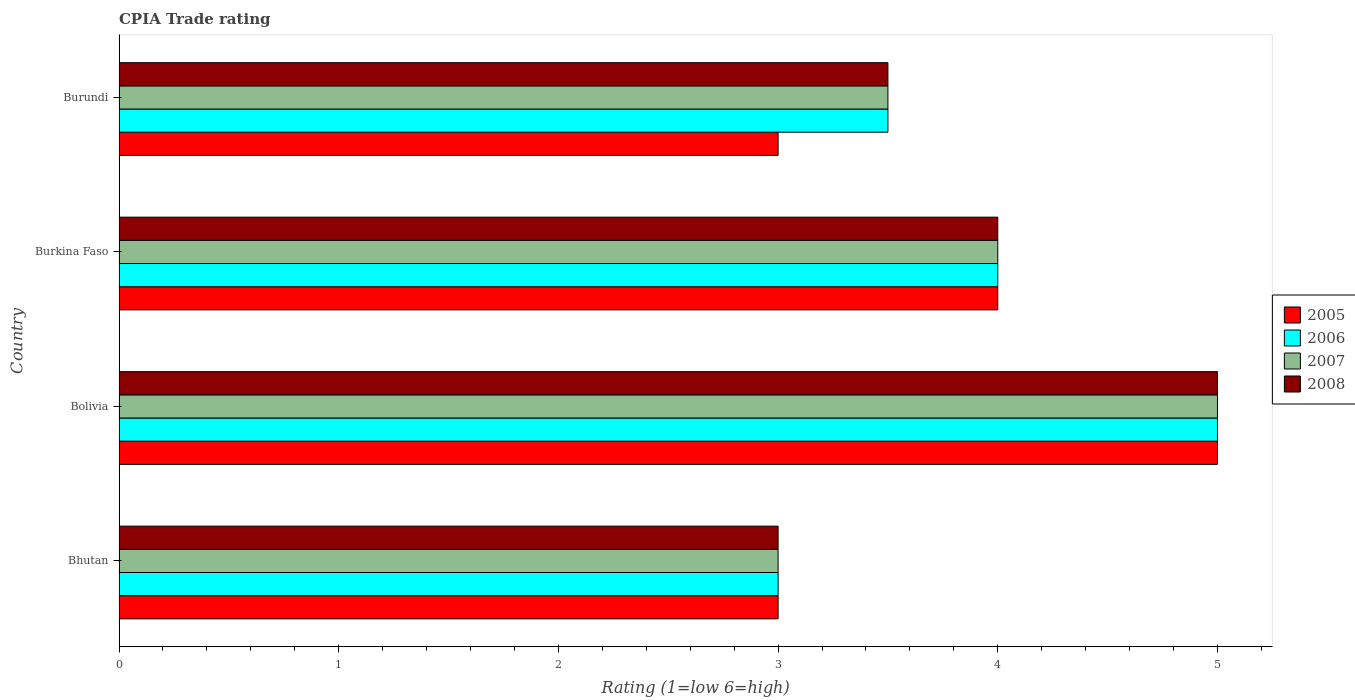How many different coloured bars are there?
Make the answer very short. 4. How many bars are there on the 2nd tick from the top?
Provide a succinct answer. 4. What is the label of the 1st group of bars from the top?
Your answer should be compact. Burundi. In how many cases, is the number of bars for a given country not equal to the number of legend labels?
Your answer should be very brief. 0. What is the CPIA rating in 2007 in Burundi?
Provide a short and direct response. 3.5. In which country was the CPIA rating in 2005 minimum?
Give a very brief answer. Bhutan. What is the total CPIA rating in 2008 in the graph?
Your answer should be compact. 15.5. What is the difference between the CPIA rating in 2006 in Bhutan and that in Burundi?
Offer a terse response. -0.5. What is the average CPIA rating in 2007 per country?
Offer a very short reply. 3.88. What is the difference between the CPIA rating in 2005 and CPIA rating in 2008 in Bolivia?
Make the answer very short. 0. What is the ratio of the CPIA rating in 2007 in Bhutan to that in Bolivia?
Give a very brief answer. 0.6. Is the CPIA rating in 2008 in Bhutan less than that in Bolivia?
Make the answer very short. Yes. In how many countries, is the CPIA rating in 2008 greater than the average CPIA rating in 2008 taken over all countries?
Provide a short and direct response. 2. Is it the case that in every country, the sum of the CPIA rating in 2007 and CPIA rating in 2008 is greater than the sum of CPIA rating in 2005 and CPIA rating in 2006?
Keep it short and to the point. No. How many bars are there?
Offer a terse response. 16. Are all the bars in the graph horizontal?
Keep it short and to the point. Yes. Does the graph contain any zero values?
Your answer should be compact. No. Where does the legend appear in the graph?
Ensure brevity in your answer.  Center right. How are the legend labels stacked?
Your answer should be compact. Vertical. What is the title of the graph?
Offer a very short reply. CPIA Trade rating. What is the label or title of the X-axis?
Your answer should be compact. Rating (1=low 6=high). What is the label or title of the Y-axis?
Offer a terse response. Country. What is the Rating (1=low 6=high) of 2006 in Bhutan?
Keep it short and to the point. 3. What is the Rating (1=low 6=high) in 2007 in Bhutan?
Give a very brief answer. 3. What is the Rating (1=low 6=high) of 2005 in Burkina Faso?
Provide a short and direct response. 4. What is the Rating (1=low 6=high) of 2006 in Burkina Faso?
Give a very brief answer. 4. What is the Rating (1=low 6=high) of 2008 in Burkina Faso?
Offer a very short reply. 4. What is the Rating (1=low 6=high) of 2006 in Burundi?
Give a very brief answer. 3.5. What is the Rating (1=low 6=high) in 2007 in Burundi?
Your answer should be very brief. 3.5. Across all countries, what is the minimum Rating (1=low 6=high) of 2005?
Give a very brief answer. 3. What is the total Rating (1=low 6=high) of 2005 in the graph?
Provide a succinct answer. 15. What is the total Rating (1=low 6=high) in 2006 in the graph?
Provide a succinct answer. 15.5. What is the total Rating (1=low 6=high) of 2007 in the graph?
Make the answer very short. 15.5. What is the difference between the Rating (1=low 6=high) in 2005 in Bhutan and that in Bolivia?
Give a very brief answer. -2. What is the difference between the Rating (1=low 6=high) of 2008 in Bhutan and that in Bolivia?
Your response must be concise. -2. What is the difference between the Rating (1=low 6=high) in 2006 in Bhutan and that in Burkina Faso?
Your answer should be very brief. -1. What is the difference between the Rating (1=low 6=high) of 2007 in Bhutan and that in Burkina Faso?
Make the answer very short. -1. What is the difference between the Rating (1=low 6=high) of 2008 in Bhutan and that in Burkina Faso?
Offer a terse response. -1. What is the difference between the Rating (1=low 6=high) of 2007 in Bhutan and that in Burundi?
Your answer should be compact. -0.5. What is the difference between the Rating (1=low 6=high) in 2008 in Bhutan and that in Burundi?
Provide a short and direct response. -0.5. What is the difference between the Rating (1=low 6=high) of 2005 in Bolivia and that in Burkina Faso?
Keep it short and to the point. 1. What is the difference between the Rating (1=low 6=high) in 2006 in Bolivia and that in Burkina Faso?
Your answer should be compact. 1. What is the difference between the Rating (1=low 6=high) in 2007 in Bolivia and that in Burkina Faso?
Ensure brevity in your answer.  1. What is the difference between the Rating (1=low 6=high) in 2008 in Bolivia and that in Burkina Faso?
Provide a short and direct response. 1. What is the difference between the Rating (1=low 6=high) in 2006 in Bolivia and that in Burundi?
Your answer should be compact. 1.5. What is the difference between the Rating (1=low 6=high) of 2007 in Bolivia and that in Burundi?
Your response must be concise. 1.5. What is the difference between the Rating (1=low 6=high) in 2008 in Bolivia and that in Burundi?
Offer a terse response. 1.5. What is the difference between the Rating (1=low 6=high) of 2006 in Burkina Faso and that in Burundi?
Provide a succinct answer. 0.5. What is the difference between the Rating (1=low 6=high) of 2007 in Burkina Faso and that in Burundi?
Offer a terse response. 0.5. What is the difference between the Rating (1=low 6=high) of 2005 in Bhutan and the Rating (1=low 6=high) of 2006 in Bolivia?
Give a very brief answer. -2. What is the difference between the Rating (1=low 6=high) in 2005 in Bhutan and the Rating (1=low 6=high) in 2007 in Bolivia?
Provide a succinct answer. -2. What is the difference between the Rating (1=low 6=high) in 2005 in Bhutan and the Rating (1=low 6=high) in 2006 in Burkina Faso?
Ensure brevity in your answer.  -1. What is the difference between the Rating (1=low 6=high) in 2007 in Bhutan and the Rating (1=low 6=high) in 2008 in Burkina Faso?
Offer a terse response. -1. What is the difference between the Rating (1=low 6=high) of 2005 in Bhutan and the Rating (1=low 6=high) of 2006 in Burundi?
Keep it short and to the point. -0.5. What is the difference between the Rating (1=low 6=high) in 2005 in Bhutan and the Rating (1=low 6=high) in 2007 in Burundi?
Give a very brief answer. -0.5. What is the difference between the Rating (1=low 6=high) in 2006 in Bhutan and the Rating (1=low 6=high) in 2007 in Burundi?
Offer a terse response. -0.5. What is the difference between the Rating (1=low 6=high) of 2007 in Bhutan and the Rating (1=low 6=high) of 2008 in Burundi?
Provide a succinct answer. -0.5. What is the difference between the Rating (1=low 6=high) of 2006 in Bolivia and the Rating (1=low 6=high) of 2007 in Burkina Faso?
Offer a terse response. 1. What is the difference between the Rating (1=low 6=high) in 2006 in Bolivia and the Rating (1=low 6=high) in 2008 in Burkina Faso?
Your answer should be compact. 1. What is the difference between the Rating (1=low 6=high) in 2007 in Bolivia and the Rating (1=low 6=high) in 2008 in Burkina Faso?
Your response must be concise. 1. What is the difference between the Rating (1=low 6=high) in 2007 in Bolivia and the Rating (1=low 6=high) in 2008 in Burundi?
Keep it short and to the point. 1.5. What is the difference between the Rating (1=low 6=high) of 2005 in Burkina Faso and the Rating (1=low 6=high) of 2006 in Burundi?
Your response must be concise. 0.5. What is the difference between the Rating (1=low 6=high) in 2006 in Burkina Faso and the Rating (1=low 6=high) in 2008 in Burundi?
Your answer should be very brief. 0.5. What is the difference between the Rating (1=low 6=high) of 2007 in Burkina Faso and the Rating (1=low 6=high) of 2008 in Burundi?
Provide a succinct answer. 0.5. What is the average Rating (1=low 6=high) in 2005 per country?
Ensure brevity in your answer.  3.75. What is the average Rating (1=low 6=high) in 2006 per country?
Keep it short and to the point. 3.88. What is the average Rating (1=low 6=high) of 2007 per country?
Give a very brief answer. 3.88. What is the average Rating (1=low 6=high) in 2008 per country?
Your response must be concise. 3.88. What is the difference between the Rating (1=low 6=high) of 2005 and Rating (1=low 6=high) of 2007 in Bhutan?
Your answer should be compact. 0. What is the difference between the Rating (1=low 6=high) in 2005 and Rating (1=low 6=high) in 2008 in Bhutan?
Ensure brevity in your answer.  0. What is the difference between the Rating (1=low 6=high) in 2006 and Rating (1=low 6=high) in 2007 in Bhutan?
Ensure brevity in your answer.  0. What is the difference between the Rating (1=low 6=high) of 2006 and Rating (1=low 6=high) of 2008 in Bhutan?
Your answer should be very brief. 0. What is the difference between the Rating (1=low 6=high) in 2005 and Rating (1=low 6=high) in 2006 in Bolivia?
Your answer should be compact. 0. What is the difference between the Rating (1=low 6=high) in 2006 and Rating (1=low 6=high) in 2008 in Bolivia?
Your answer should be very brief. 0. What is the difference between the Rating (1=low 6=high) of 2007 and Rating (1=low 6=high) of 2008 in Bolivia?
Your response must be concise. 0. What is the difference between the Rating (1=low 6=high) in 2005 and Rating (1=low 6=high) in 2007 in Burkina Faso?
Offer a very short reply. 0. What is the difference between the Rating (1=low 6=high) of 2006 and Rating (1=low 6=high) of 2007 in Burkina Faso?
Your answer should be compact. 0. What is the difference between the Rating (1=low 6=high) of 2007 and Rating (1=low 6=high) of 2008 in Burkina Faso?
Make the answer very short. 0. What is the difference between the Rating (1=low 6=high) in 2005 and Rating (1=low 6=high) in 2006 in Burundi?
Your answer should be compact. -0.5. What is the difference between the Rating (1=low 6=high) in 2005 and Rating (1=low 6=high) in 2007 in Burundi?
Keep it short and to the point. -0.5. What is the difference between the Rating (1=low 6=high) in 2006 and Rating (1=low 6=high) in 2007 in Burundi?
Your answer should be very brief. 0. What is the difference between the Rating (1=low 6=high) of 2007 and Rating (1=low 6=high) of 2008 in Burundi?
Your answer should be compact. 0. What is the ratio of the Rating (1=low 6=high) in 2005 in Bhutan to that in Bolivia?
Provide a succinct answer. 0.6. What is the ratio of the Rating (1=low 6=high) in 2005 in Bhutan to that in Burkina Faso?
Ensure brevity in your answer.  0.75. What is the ratio of the Rating (1=low 6=high) of 2007 in Bhutan to that in Burkina Faso?
Your answer should be very brief. 0.75. What is the ratio of the Rating (1=low 6=high) in 2008 in Bhutan to that in Burkina Faso?
Your answer should be compact. 0.75. What is the ratio of the Rating (1=low 6=high) of 2005 in Bhutan to that in Burundi?
Give a very brief answer. 1. What is the ratio of the Rating (1=low 6=high) in 2006 in Bhutan to that in Burundi?
Offer a very short reply. 0.86. What is the ratio of the Rating (1=low 6=high) in 2008 in Bhutan to that in Burundi?
Keep it short and to the point. 0.86. What is the ratio of the Rating (1=low 6=high) of 2007 in Bolivia to that in Burkina Faso?
Give a very brief answer. 1.25. What is the ratio of the Rating (1=low 6=high) of 2008 in Bolivia to that in Burkina Faso?
Offer a terse response. 1.25. What is the ratio of the Rating (1=low 6=high) in 2005 in Bolivia to that in Burundi?
Provide a short and direct response. 1.67. What is the ratio of the Rating (1=low 6=high) in 2006 in Bolivia to that in Burundi?
Offer a terse response. 1.43. What is the ratio of the Rating (1=low 6=high) of 2007 in Bolivia to that in Burundi?
Make the answer very short. 1.43. What is the ratio of the Rating (1=low 6=high) of 2008 in Bolivia to that in Burundi?
Offer a terse response. 1.43. What is the ratio of the Rating (1=low 6=high) of 2007 in Burkina Faso to that in Burundi?
Make the answer very short. 1.14. What is the difference between the highest and the second highest Rating (1=low 6=high) in 2006?
Ensure brevity in your answer.  1. What is the difference between the highest and the second highest Rating (1=low 6=high) in 2007?
Make the answer very short. 1. What is the difference between the highest and the second highest Rating (1=low 6=high) in 2008?
Keep it short and to the point. 1. What is the difference between the highest and the lowest Rating (1=low 6=high) of 2006?
Offer a very short reply. 2. What is the difference between the highest and the lowest Rating (1=low 6=high) of 2007?
Give a very brief answer. 2. 